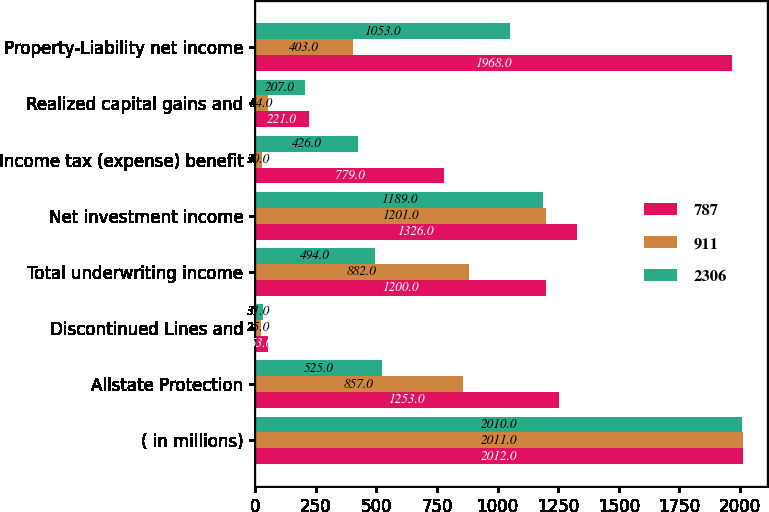<chart> <loc_0><loc_0><loc_500><loc_500><stacked_bar_chart><ecel><fcel>( in millions)<fcel>Allstate Protection<fcel>Discontinued Lines and<fcel>Total underwriting income<fcel>Net investment income<fcel>Income tax (expense) benefit<fcel>Realized capital gains and<fcel>Property-Liability net income<nl><fcel>787<fcel>2012<fcel>1253<fcel>53<fcel>1200<fcel>1326<fcel>779<fcel>221<fcel>1968<nl><fcel>911<fcel>2011<fcel>857<fcel>25<fcel>882<fcel>1201<fcel>30<fcel>54<fcel>403<nl><fcel>2306<fcel>2010<fcel>525<fcel>31<fcel>494<fcel>1189<fcel>426<fcel>207<fcel>1053<nl></chart> 